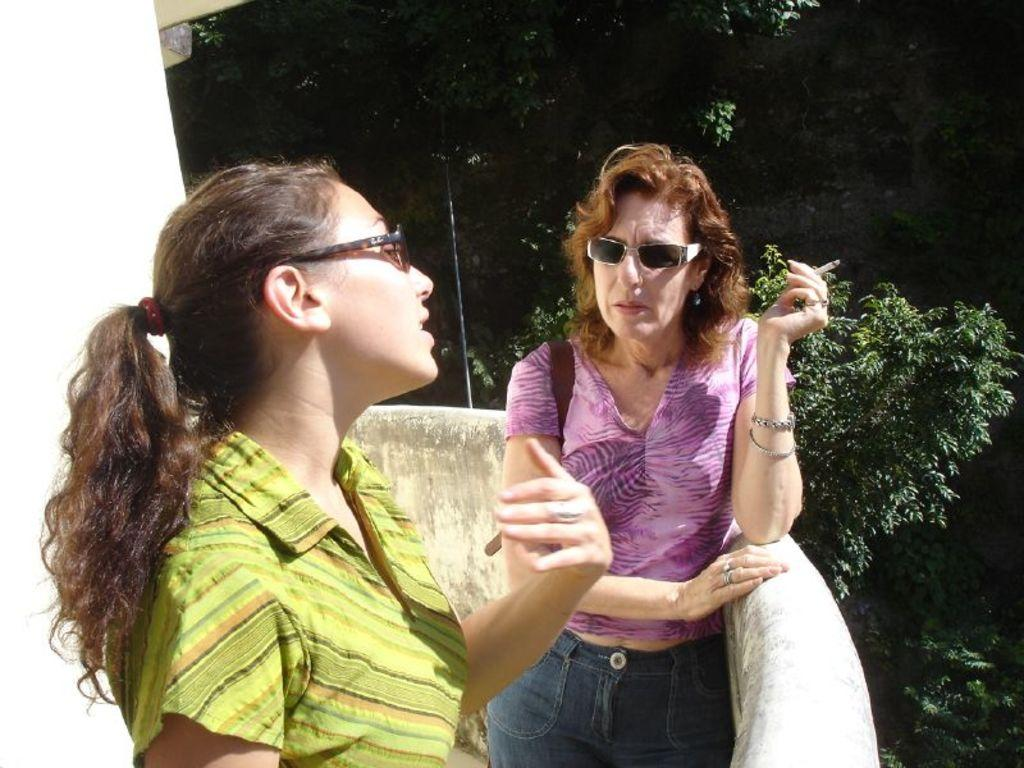How many people are present in the image? There are two people standing in the building. What can be seen in the background of the image? There are trees in the background of the image. What color is the ink on the leg of the person on the left? There is no ink or leg mentioned in the image; it only shows two people standing in a building with trees in the background. 